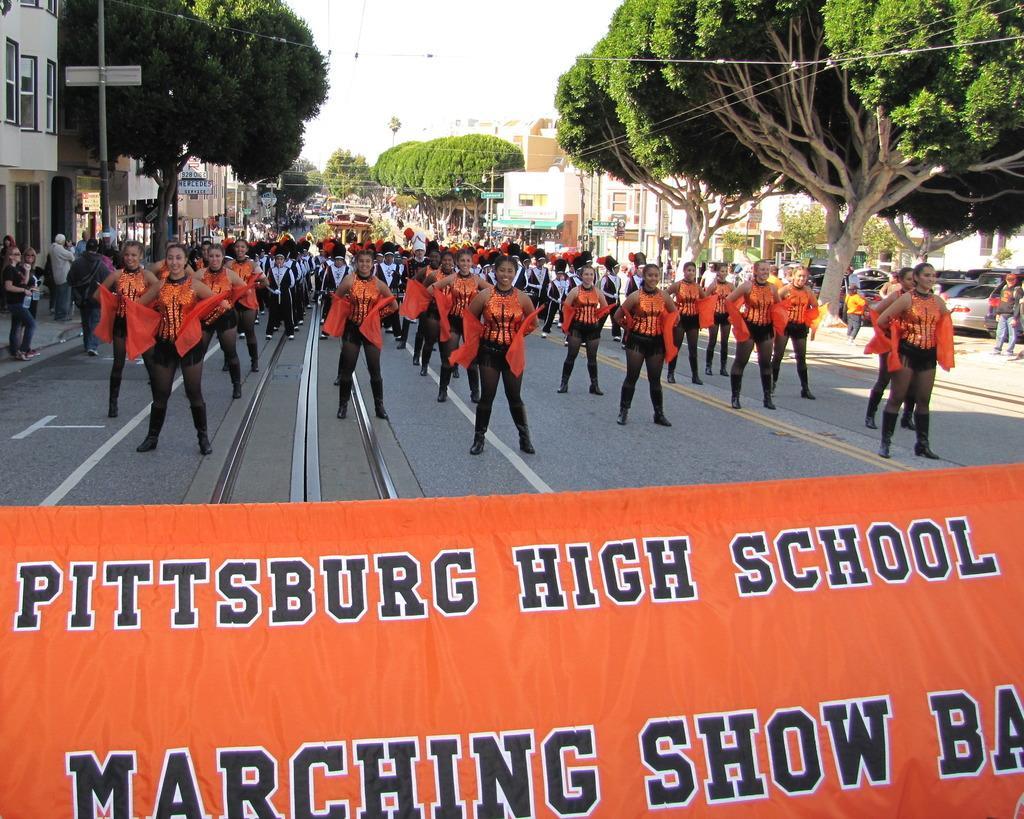In one or two sentences, can you explain what this image depicts? At the bottom there is a banner. In the middle of the picture we can see lot of people on the road. On the left we can see buildings, poles, trees, board, footpath and people. On the right there are trees and buildings. In the center of the background there are trees, buildings and people. At the top we can see cables and sky. 